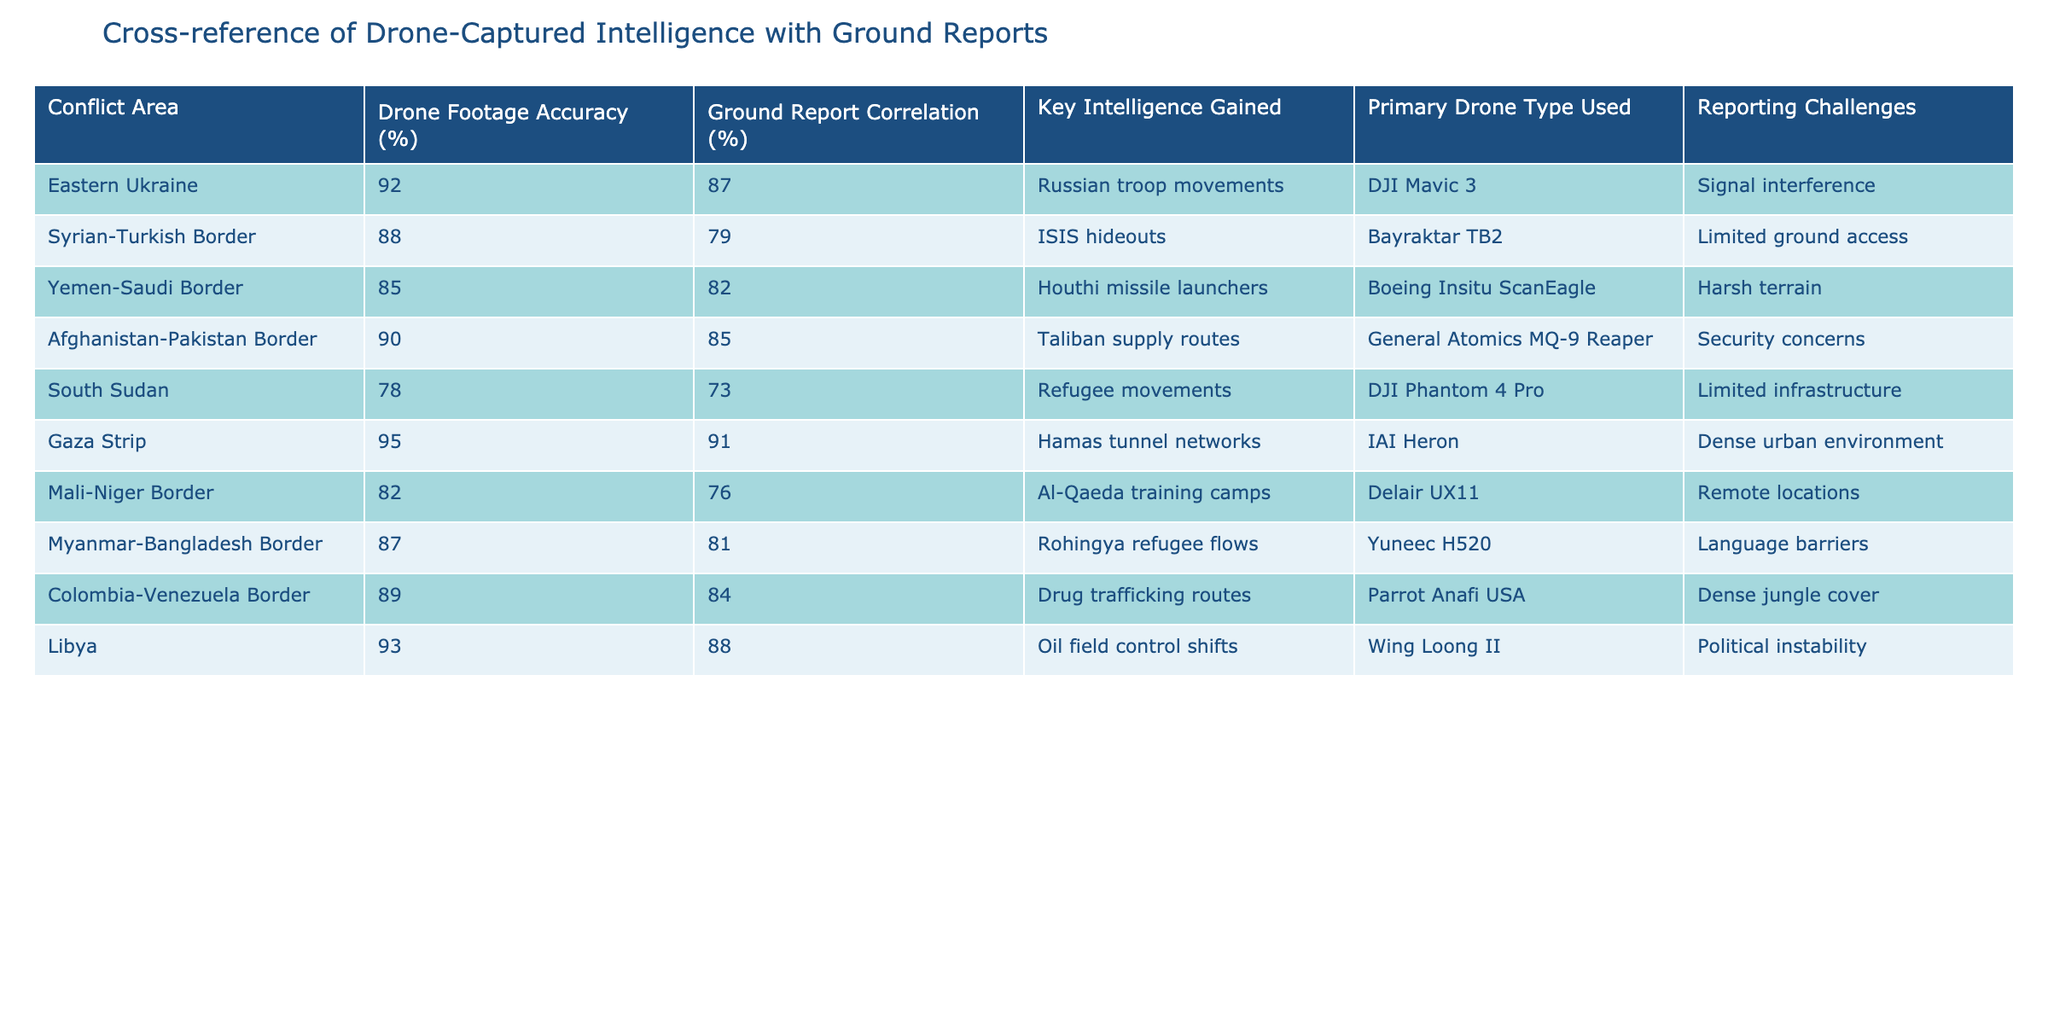What is the highest Drone Footage Accuracy percentage recorded? By examining the "Drone Footage Accuracy (%)" column, I can see that the highest value is 95 for the Gaza Strip.
Answer: 95 Which conflict area has the lowest Ground Report Correlation percentage? Looking at the "Ground Report Correlation (%)" column, the lowest value is 73, which corresponds to South Sudan.
Answer: 73 How many conflict areas have a Drone Footage Accuracy of 90% or above? The areas with at least 90% accuracy are Eastern Ukraine (92%), Gaza Strip (95%), Afghanistan-Pakistan Border (90%), and Libya (93%). Thus, there are four such areas.
Answer: 4 Is there a direct relationship between Drone Footage Accuracy and Ground Report Correlation in the data? By examining the values in both columns, there is no direct correlation since the values do not consistently increase or decrease together. For example, the Gaza Strip has the highest accuracy (95%) and the highest correlation (91%), while South Sudan has the lowest scores in both categories. However, other areas show discrepancies.
Answer: No What is the average Ground Report Correlation percentage of the conflict areas analyzed? The Ground Report Correlation percentages are: 87, 79, 82, 85, 73, 91, 76, 81, 84, 88. Summing these gives  87 + 79 + 82 + 85 + 73 + 91 + 76 + 81 + 84 + 88 =  915. Dividing this sum by the number of areas (10) gives an average of 91.5.
Answer: 91.5 Which drone type was most commonly used in the areas with the highest intelligence gained? Analyzing the "Primary Drone Type Used" column in relation to the "Key Intelligence Gained," the IAI Heron was used in the Gaza Strip, which had the highest intelligence gain regarding Hamas tunnel networks. Other drones are used for different areas, but none achieved a higher intelligence gain.
Answer: IAI Heron What is the difference in Ground Report Correlation between the Eastern Ukraine and the Yemen-Saudi Border? The Ground Report Correlation for Eastern Ukraine is 87%, while for Yemen-Saudi Border, it is 82%. The difference is 87 - 82 = 5.
Answer: 5 Which conflict area reported the best combination of high Drone Footage Accuracy and Ground Report Correlation? Both the Gaza Strip and Libya reported high values for their Drone Footage Accuracy and Ground Report Correlation, but the Gaza Strip has the highest accuracy (95%) and a correlation of 91%, making it the best overall.
Answer: Gaza Strip Is there any conflict area where the Drone Footage Accuracy is less than the Ground Report Correlation? Checking the values in the respective columns, South Sudan shows Drone Footage Accuracy of 78%, which is lower than its Ground Report Correlation of 73%. Thus, it is a case where this is true.
Answer: No What percentage of the reported intelligence in the conflict areas concerns troop movements? From the "Key Intelligence Gained" column, only Eastern Ukraine mentions troop movements. Since there are 10 conflict areas, it represents 1 out of 10, which is 10%.
Answer: 10% 